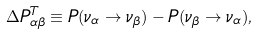<formula> <loc_0><loc_0><loc_500><loc_500>\Delta P ^ { T } _ { \alpha \beta } \equiv P ( \nu _ { \alpha } \to \nu _ { \beta } ) - P ( \nu _ { \beta } \to \nu _ { \alpha } ) ,</formula> 